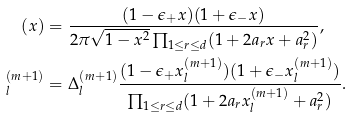<formula> <loc_0><loc_0><loc_500><loc_500>( x ) & = \frac { ( 1 - \epsilon _ { + } x ) ( 1 + \epsilon _ { - } x ) } { 2 \pi \sqrt { 1 - x ^ { 2 } } \prod _ { 1 \leq r \leq d } ( 1 + 2 a _ { r } x + a _ { r } ^ { 2 } ) } , \\ ^ { ( m + 1 ) } _ { l } & = \Delta _ { l } ^ { ( m + 1 ) } \frac { ( 1 - \epsilon _ { + } x ^ { ( m + 1 ) } _ { l } ) ( 1 + \epsilon _ { - } x ^ { ( m + 1 ) } _ { l } ) } { \prod _ { 1 \leq r \leq d } ( 1 + 2 a _ { r } x ^ { ( m + 1 ) } _ { l } + a _ { r } ^ { 2 } ) } .</formula> 